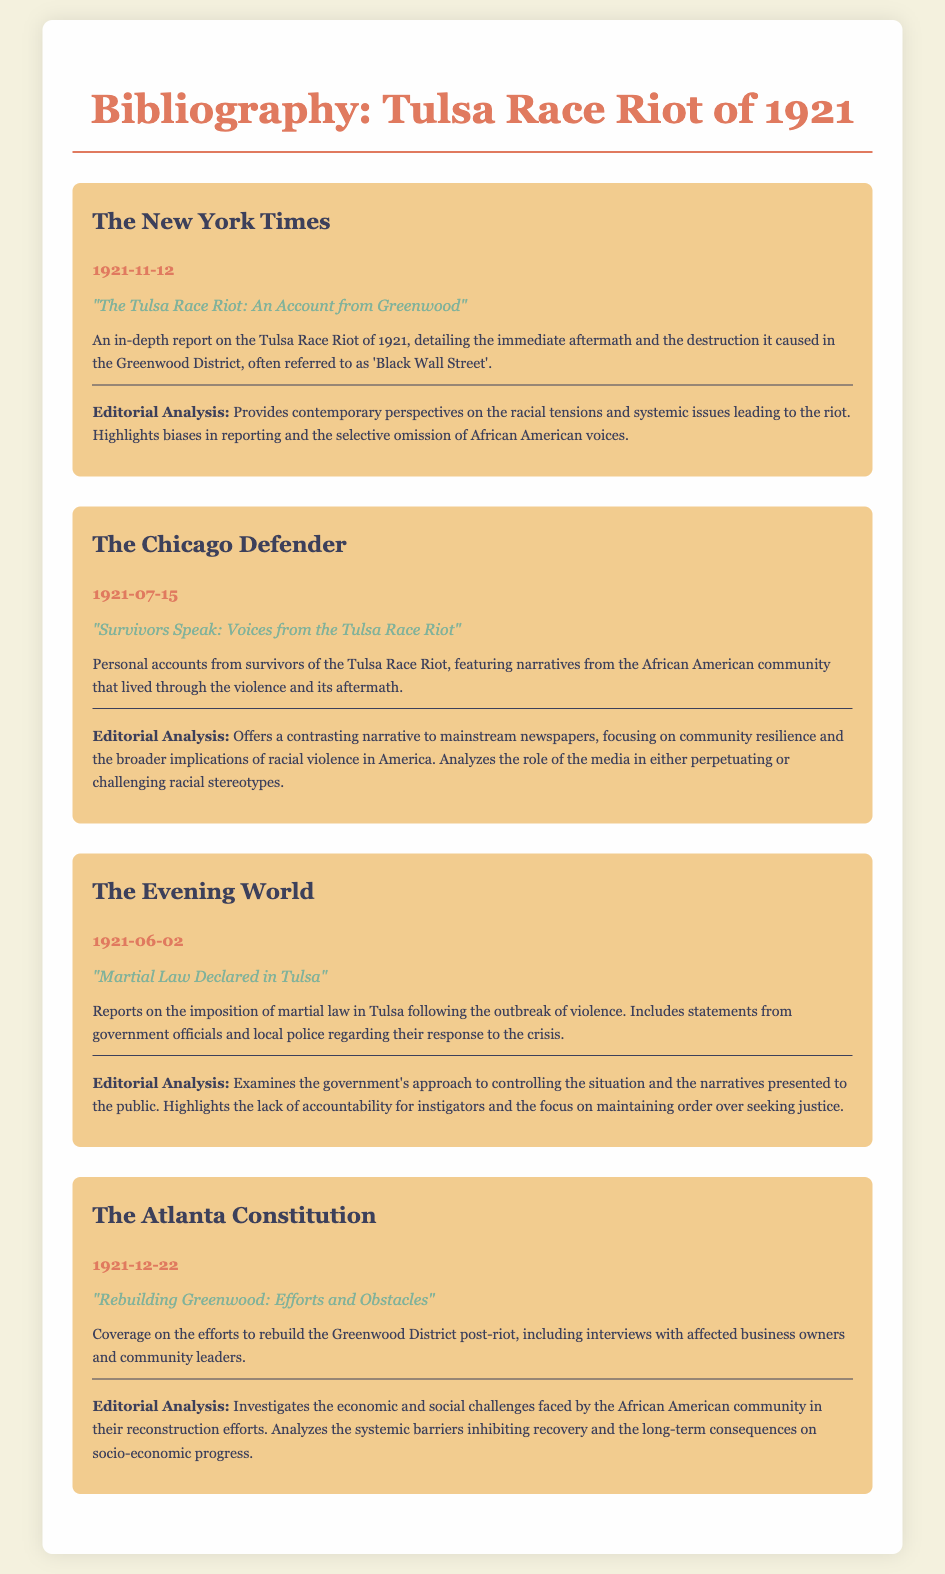What is the title of the New York Times article? The title is provided in the document under the New York Times entry, which is "The Tulsa Race Riot: An Account from Greenwood".
Answer: "The Tulsa Race Riot: An Account from Greenwood" What date was the article from The Chicago Defender published? The publication date is given in the document, specifically for The Chicago Defender article, which is July 15, 1921.
Answer: 1921-07-15 What key issue does The Evening World article address? The document summarizes The Evening World's article as reporting on the imposition of martial law in Tulsa.
Answer: Martial Law Declared in Tulsa How many sources are listed in the bibliography? The total number of sources, as indicated in the document, is four distinct newspaper articles.
Answer: 4 What common theme is highlighted in the editorial analysis of The New York Times? The analysis points out significant biases and the selective omission of African American voices in the reporting of the riot.
Answer: Biases in reporting Which source features personal accounts from survivors? The document indicates that The Chicago Defender includes personal accounts from survivors of the Tulsa Race Riot.
Answer: The Chicago Defender What is the publication date of the article discussing rebuilding Greenwood? This information is specified in the document, showing that The Atlanta Constitution article was published on December 22, 1921.
Answer: 1921-12-22 What aspect of the government's response does The Evening World analyze? The analysis focuses on the government's narrative presented to the public regarding the control of the situation.
Answer: Government's approach to controlling the situation What does the analysis of The Atlanta Constitution investigate? The editorial analysis investigates the economic and social challenges faced by the African American community.
Answer: Economic and social challenges 